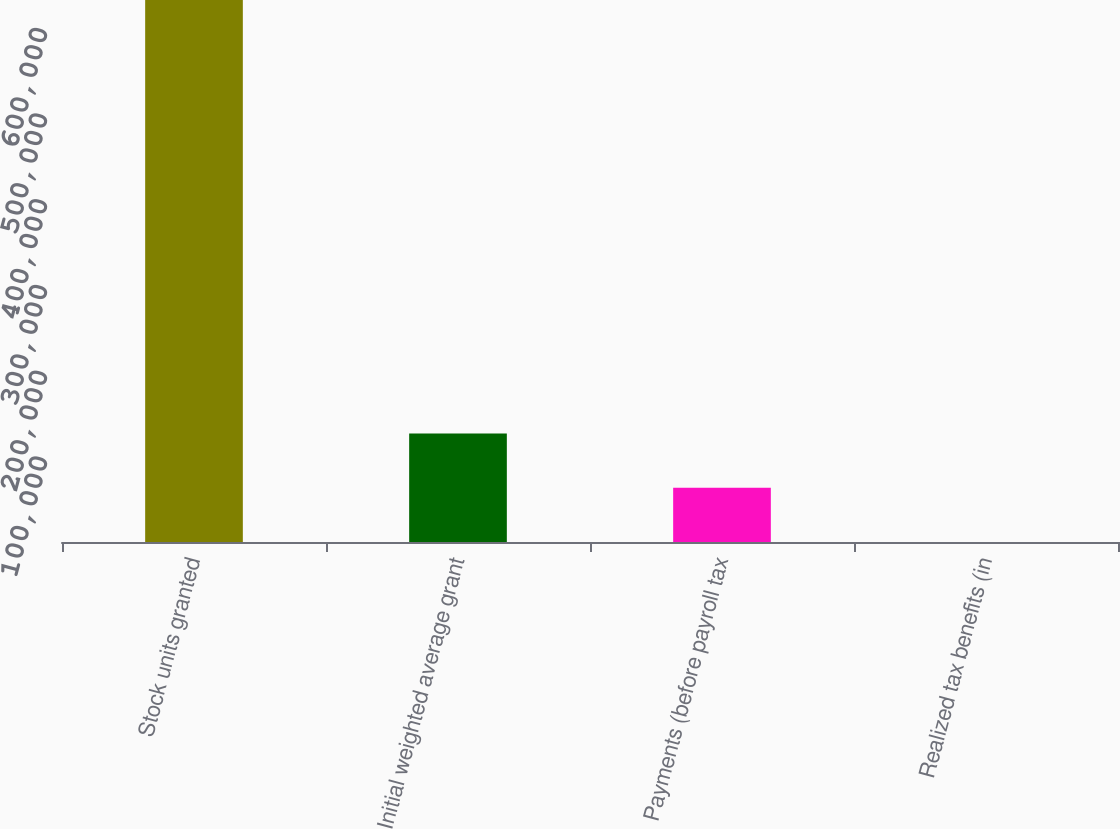Convert chart to OTSL. <chart><loc_0><loc_0><loc_500><loc_500><bar_chart><fcel>Stock units granted<fcel>Initial weighted average grant<fcel>Payments (before payroll tax<fcel>Realized tax benefits (in<nl><fcel>632261<fcel>126460<fcel>63234.7<fcel>9.5<nl></chart> 